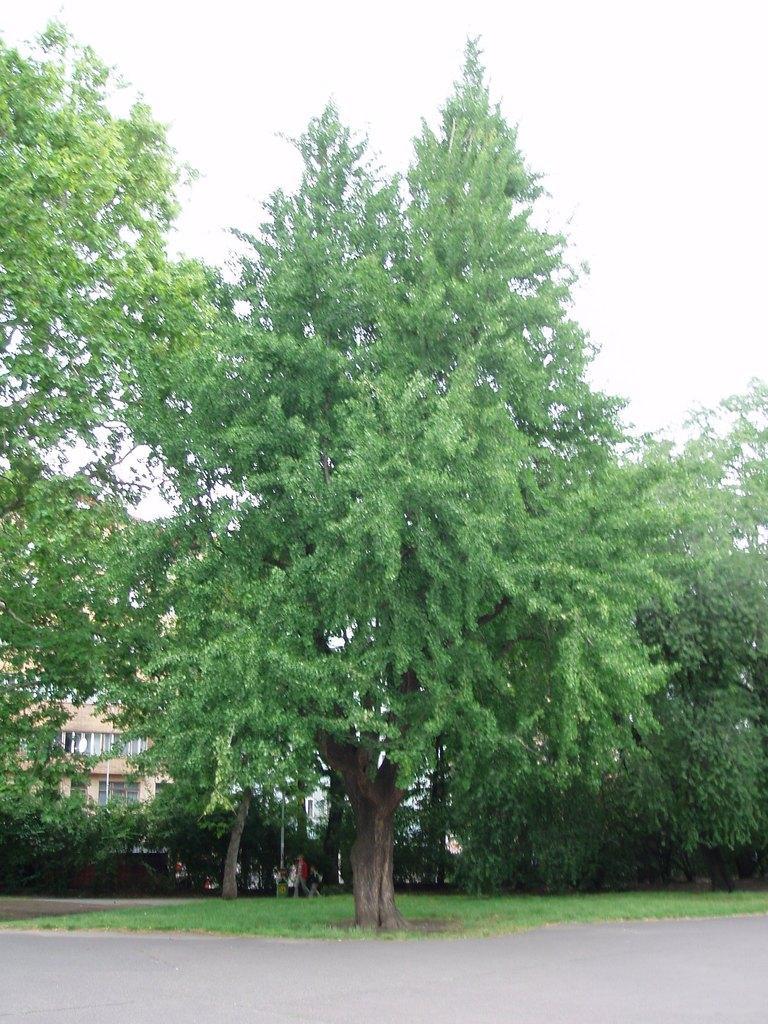Could you give a brief overview of what you see in this image? In this image I can see trees in green color, background I can see a building in cream and white color, and the sky is in white color. 